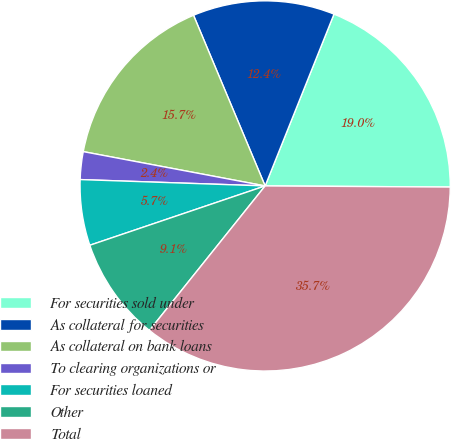Convert chart. <chart><loc_0><loc_0><loc_500><loc_500><pie_chart><fcel>For securities sold under<fcel>As collateral for securities<fcel>As collateral on bank loans<fcel>To clearing organizations or<fcel>For securities loaned<fcel>Other<fcel>Total<nl><fcel>19.03%<fcel>12.39%<fcel>15.71%<fcel>2.42%<fcel>5.74%<fcel>9.06%<fcel>35.65%<nl></chart> 